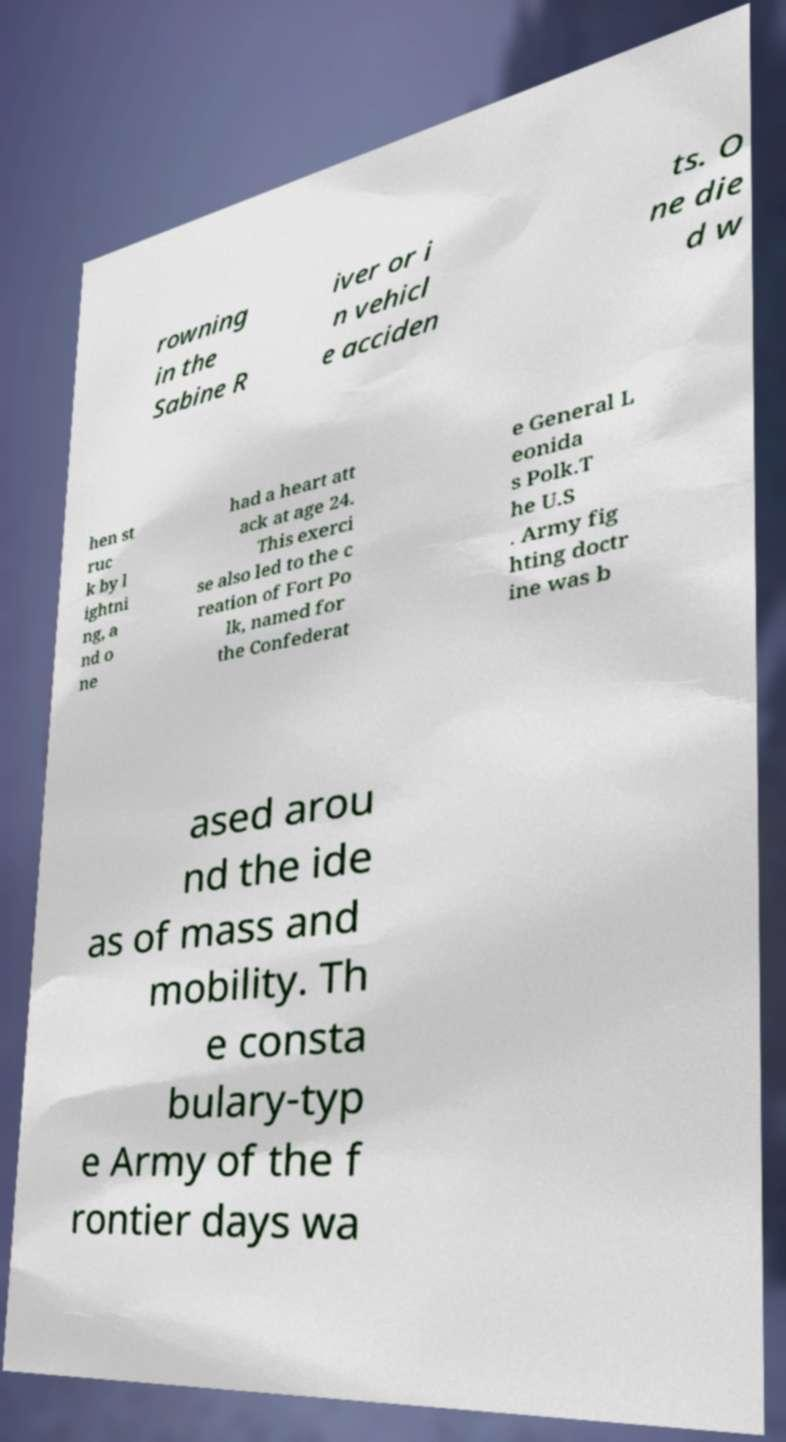There's text embedded in this image that I need extracted. Can you transcribe it verbatim? rowning in the Sabine R iver or i n vehicl e acciden ts. O ne die d w hen st ruc k by l ightni ng, a nd o ne had a heart att ack at age 24. This exerci se also led to the c reation of Fort Po lk, named for the Confederat e General L eonida s Polk.T he U.S . Army fig hting doctr ine was b ased arou nd the ide as of mass and mobility. Th e consta bulary-typ e Army of the f rontier days wa 